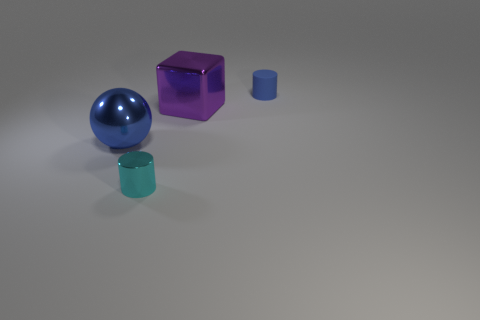Is there anything else that has the same material as the tiny blue object?
Provide a short and direct response. No. What number of small cylinders are the same color as the large shiny sphere?
Give a very brief answer. 1. There is a big blue ball to the left of the shiny object that is in front of the blue thing that is left of the small blue object; what is its material?
Make the answer very short. Metal. What color is the large shiny object that is on the left side of the tiny cylinder on the left side of the big block?
Offer a very short reply. Blue. What number of tiny objects are blue things or blue cylinders?
Provide a short and direct response. 1. What number of tiny cyan objects are made of the same material as the purple block?
Your answer should be very brief. 1. What is the size of the cylinder that is to the left of the large shiny block?
Give a very brief answer. Small. The blue thing that is in front of the tiny matte cylinder on the right side of the large blue metal sphere is what shape?
Keep it short and to the point. Sphere. What number of small shiny cylinders are to the right of the cylinder that is on the left side of the tiny cylinder behind the ball?
Provide a succinct answer. 0. Is the number of small cyan metallic objects in front of the cyan thing less than the number of tiny blue rubber objects?
Make the answer very short. Yes. 